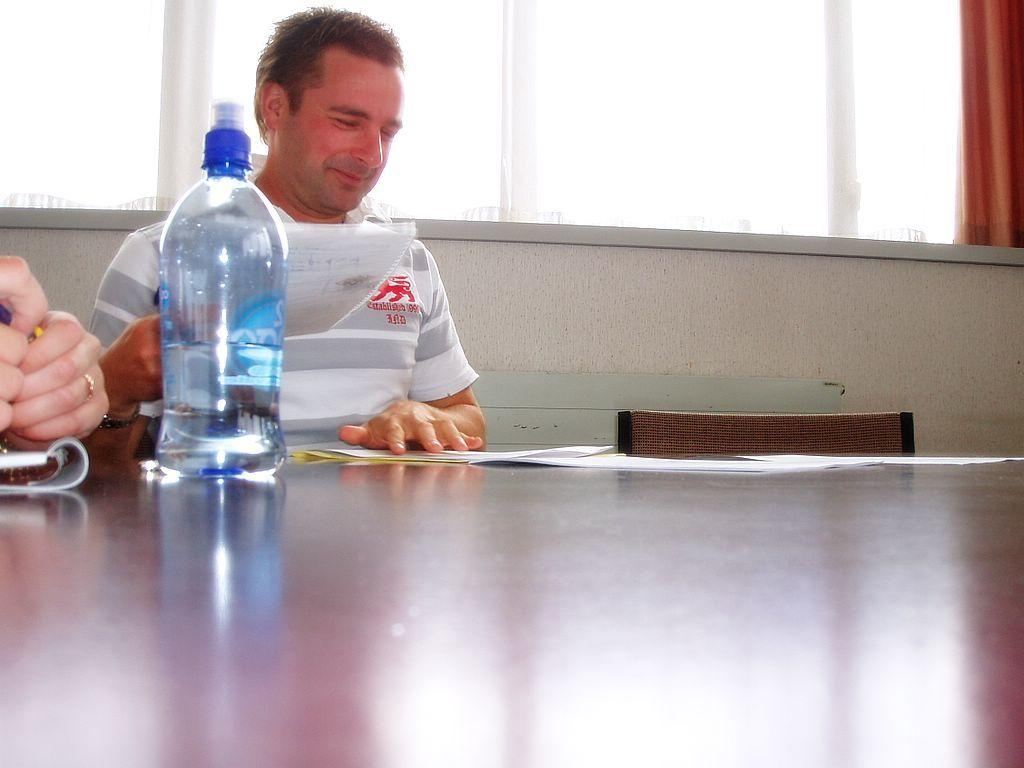What is the man in the image doing? The man is sitting on a chair in the image. What is located on the table in the image? There is a bottle, papers, a book, and a glass on the table in the image. Can you describe the curtain in the image? There is a curtain in the image, but its specific appearance or color is not mentioned in the facts. How many objects are on the table in the image? There are four objects on the table: a bottle, papers, a book, and a glass. What type of pets are visible in the image? There are no pets visible in the image. What color is the rose on the table in the image? There is no rose present in the image. 